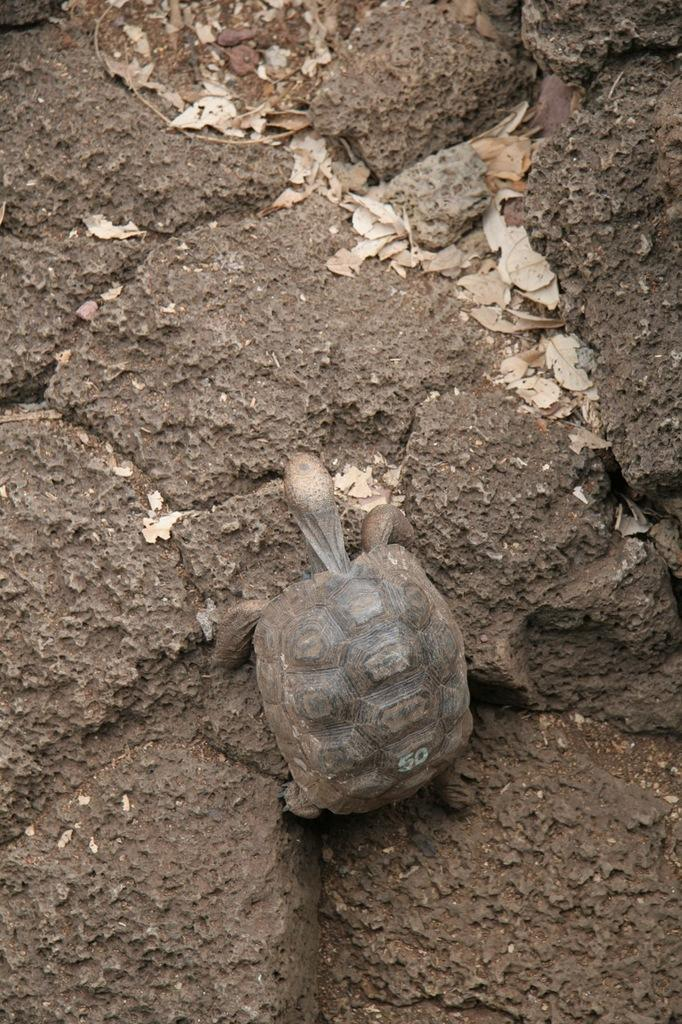What animal is present in the image? There is a turtle in the image. What type of surface is the turtle on? The turtle is on a muddy surface. How many cows are visible in the image? There are no cows present in the image; it features a turtle on a muddy surface. What type of ring is the turtle wearing on its leg? The turtle is not wearing any ring in the image. 